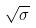<formula> <loc_0><loc_0><loc_500><loc_500>\sqrt { \sigma }</formula> 